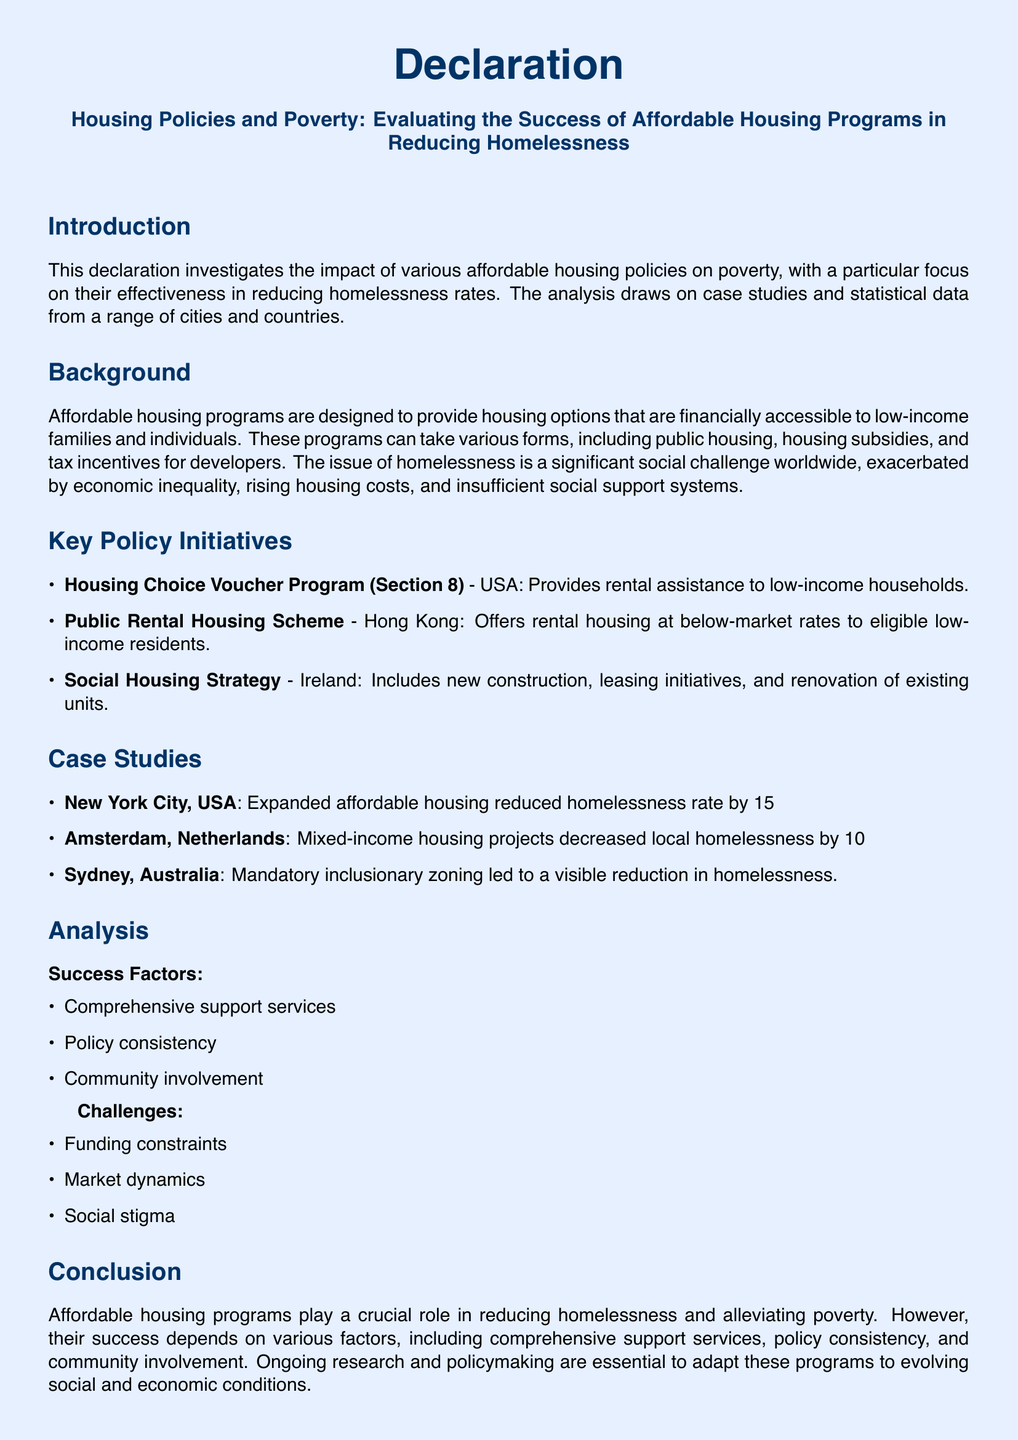What is the title of the declaration? The title reflects the main focus of the document on evaluating housing policies and their impact on poverty.
Answer: Housing Policies and Poverty: Evaluating the Success of Affordable Housing Programs in Reducing Homelessness Which affordable housing program is implemented in the USA? This program is specifically mentioned as part of the key initiatives aimed at assisting low-income households.
Answer: Housing Choice Voucher Program (Section 8) What percentage did New York City reduce its homelessness rate? This percentage indicates the effectiveness of affordable housing measures in a specific case study mentioned in the document.
Answer: 15% What is one key success factor identified in the document? This factor is crucial for the overall success of affordable housing programs and is listed under the analysis section.
Answer: Comprehensive support services Which country has a Public Rental Housing Scheme? This country is highlighted in the document as part of the key policy initiatives aimed at providing affordable housing solutions.
Answer: Hong Kong What is a significant challenge faced by affordable housing programs? This challenge reflects an obstacle encountered in the implementation and success of these programs as stated in the analysis.
Answer: Funding constraints How many recommendations are made in the document? The number of recommendations indicates the actionable steps proposed to improve affordable housing programs.
Answer: Four What is the purpose of the declaration? The purpose is defined within the introduction, indicating the primary focus of the document's analysis.
Answer: Investigates the impact of various affordable housing policies on poverty 